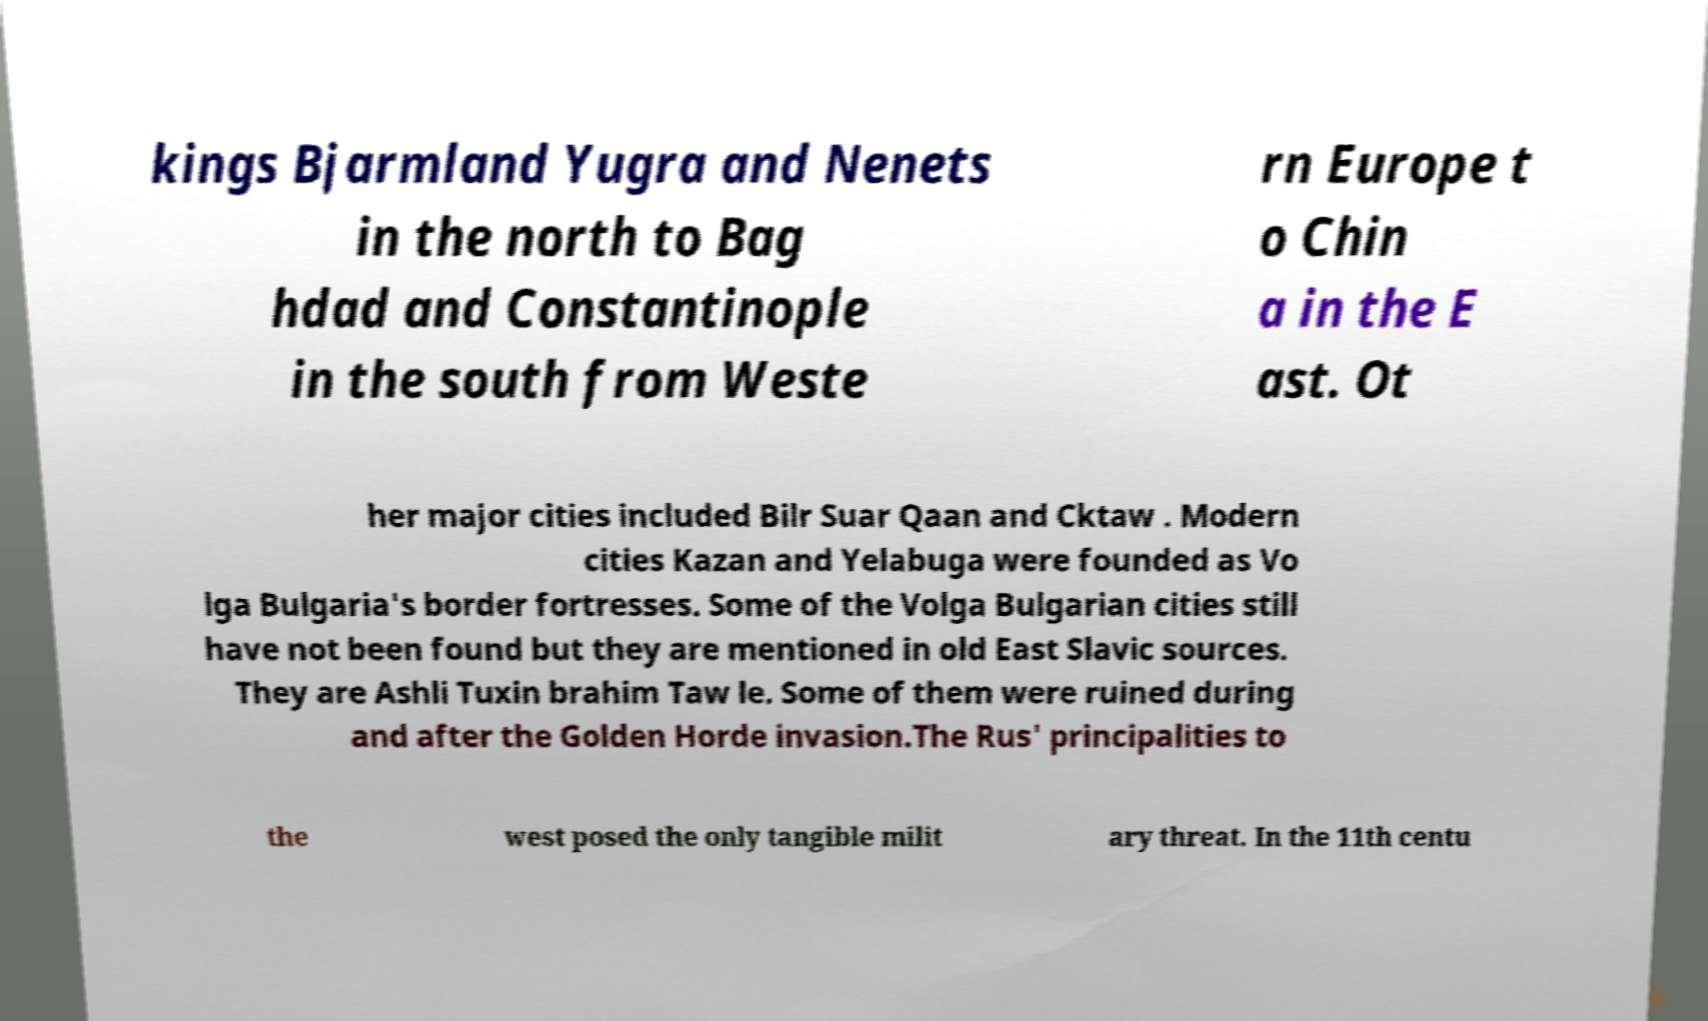I need the written content from this picture converted into text. Can you do that? kings Bjarmland Yugra and Nenets in the north to Bag hdad and Constantinople in the south from Weste rn Europe t o Chin a in the E ast. Ot her major cities included Bilr Suar Qaan and Cktaw . Modern cities Kazan and Yelabuga were founded as Vo lga Bulgaria's border fortresses. Some of the Volga Bulgarian cities still have not been found but they are mentioned in old East Slavic sources. They are Ashli Tuxin brahim Taw le. Some of them were ruined during and after the Golden Horde invasion.The Rus' principalities to the west posed the only tangible milit ary threat. In the 11th centu 